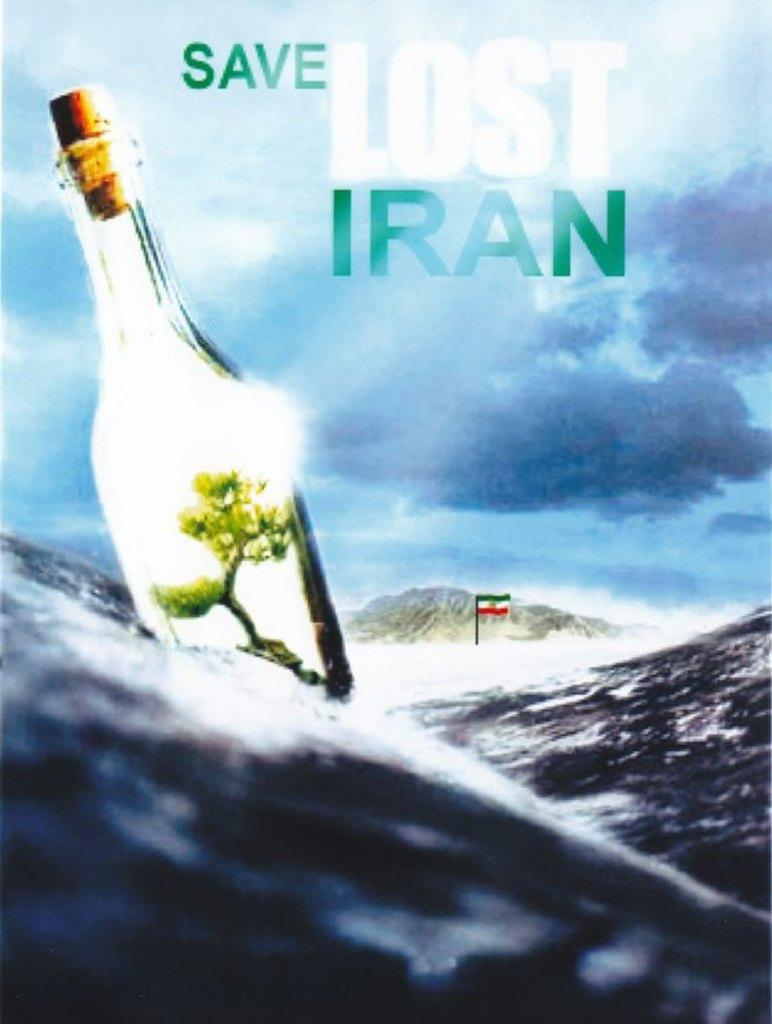Provide a one-sentence caption for the provided image. a poster of a bottle in the ocean that says 'save lost iran' on it. 